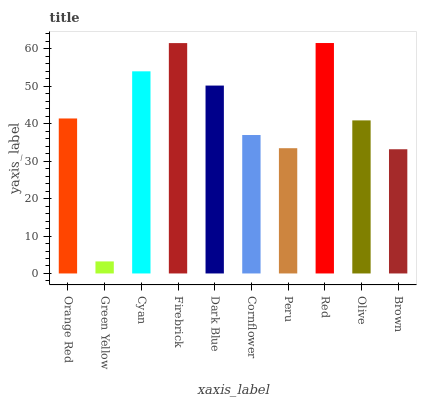Is Green Yellow the minimum?
Answer yes or no. Yes. Is Red the maximum?
Answer yes or no. Yes. Is Cyan the minimum?
Answer yes or no. No. Is Cyan the maximum?
Answer yes or no. No. Is Cyan greater than Green Yellow?
Answer yes or no. Yes. Is Green Yellow less than Cyan?
Answer yes or no. Yes. Is Green Yellow greater than Cyan?
Answer yes or no. No. Is Cyan less than Green Yellow?
Answer yes or no. No. Is Orange Red the high median?
Answer yes or no. Yes. Is Olive the low median?
Answer yes or no. Yes. Is Green Yellow the high median?
Answer yes or no. No. Is Red the low median?
Answer yes or no. No. 